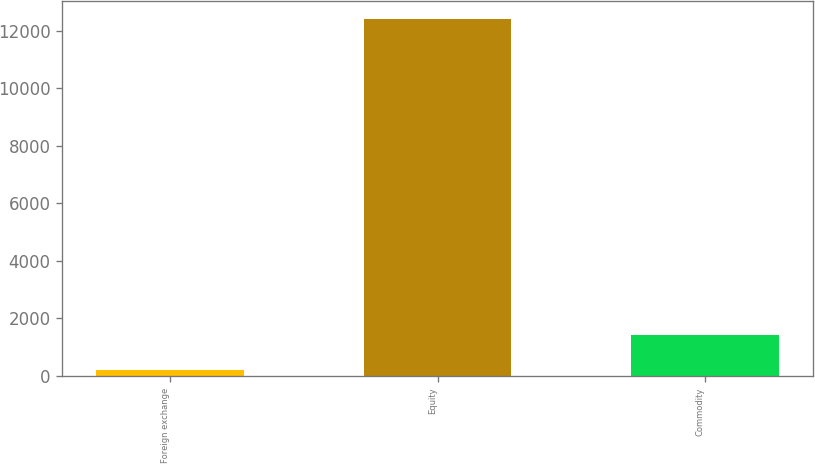Convert chart to OTSL. <chart><loc_0><loc_0><loc_500><loc_500><bar_chart><fcel>Foreign exchange<fcel>Equity<fcel>Commodity<nl><fcel>211<fcel>12412<fcel>1431.1<nl></chart> 